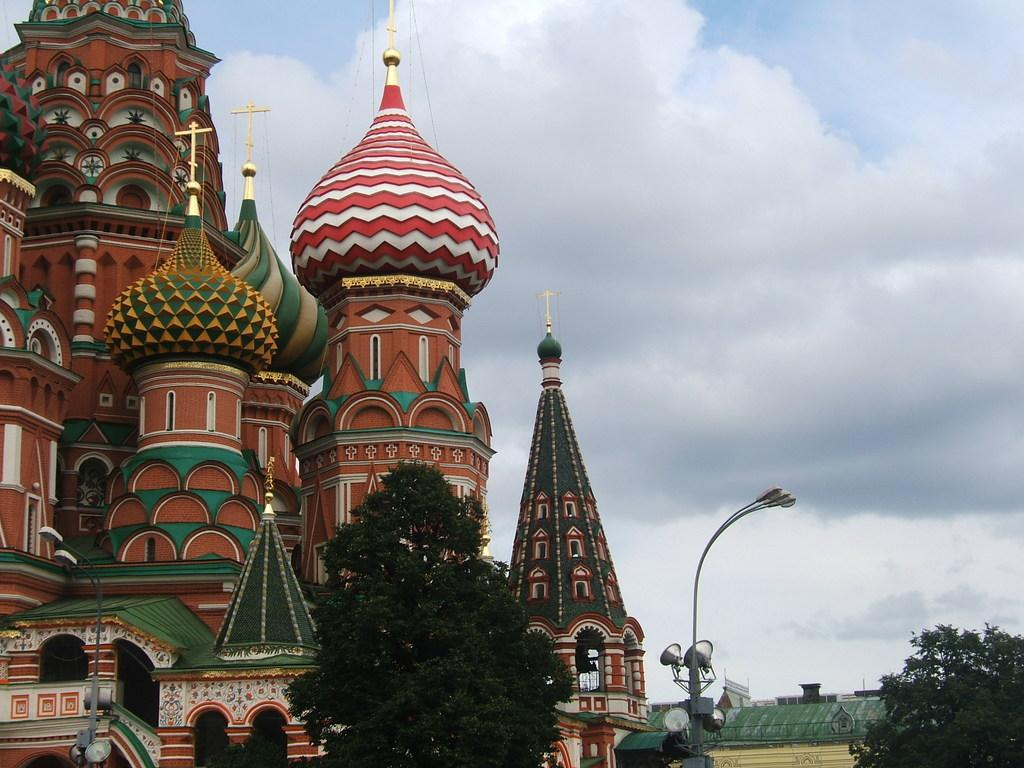What type of structures can be seen in the image? There are buildings in the image. What type of vegetation is present in the image? There are trees in the image. What other objects can be seen in the image? There are poles in the image. What is visible in the sky in the image? There are clouds in the image. What is the average income of the people living in the houses in the image? There are no houses present in the image, only buildings. What type of muscle can be seen in the image? There are no muscles visible in the image. 